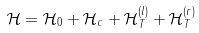<formula> <loc_0><loc_0><loc_500><loc_500>\mathcal { H } = \mathcal { H } _ { 0 } + \mathcal { H } _ { c } + \mathcal { H } _ { T } ^ { ( l ) } + \mathcal { H } _ { T } ^ { ( r ) }</formula> 